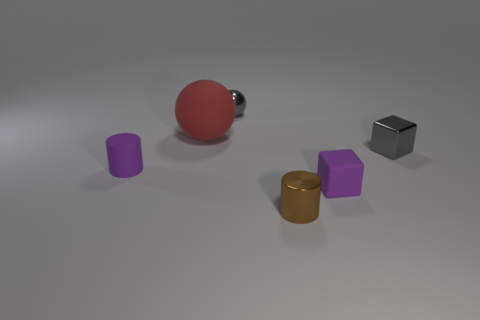Add 3 large red things. How many objects exist? 9 Subtract all balls. How many objects are left? 4 Add 4 purple matte cubes. How many purple matte cubes exist? 5 Subtract 0 blue cylinders. How many objects are left? 6 Subtract all small metal cubes. Subtract all red matte objects. How many objects are left? 4 Add 6 big balls. How many big balls are left? 7 